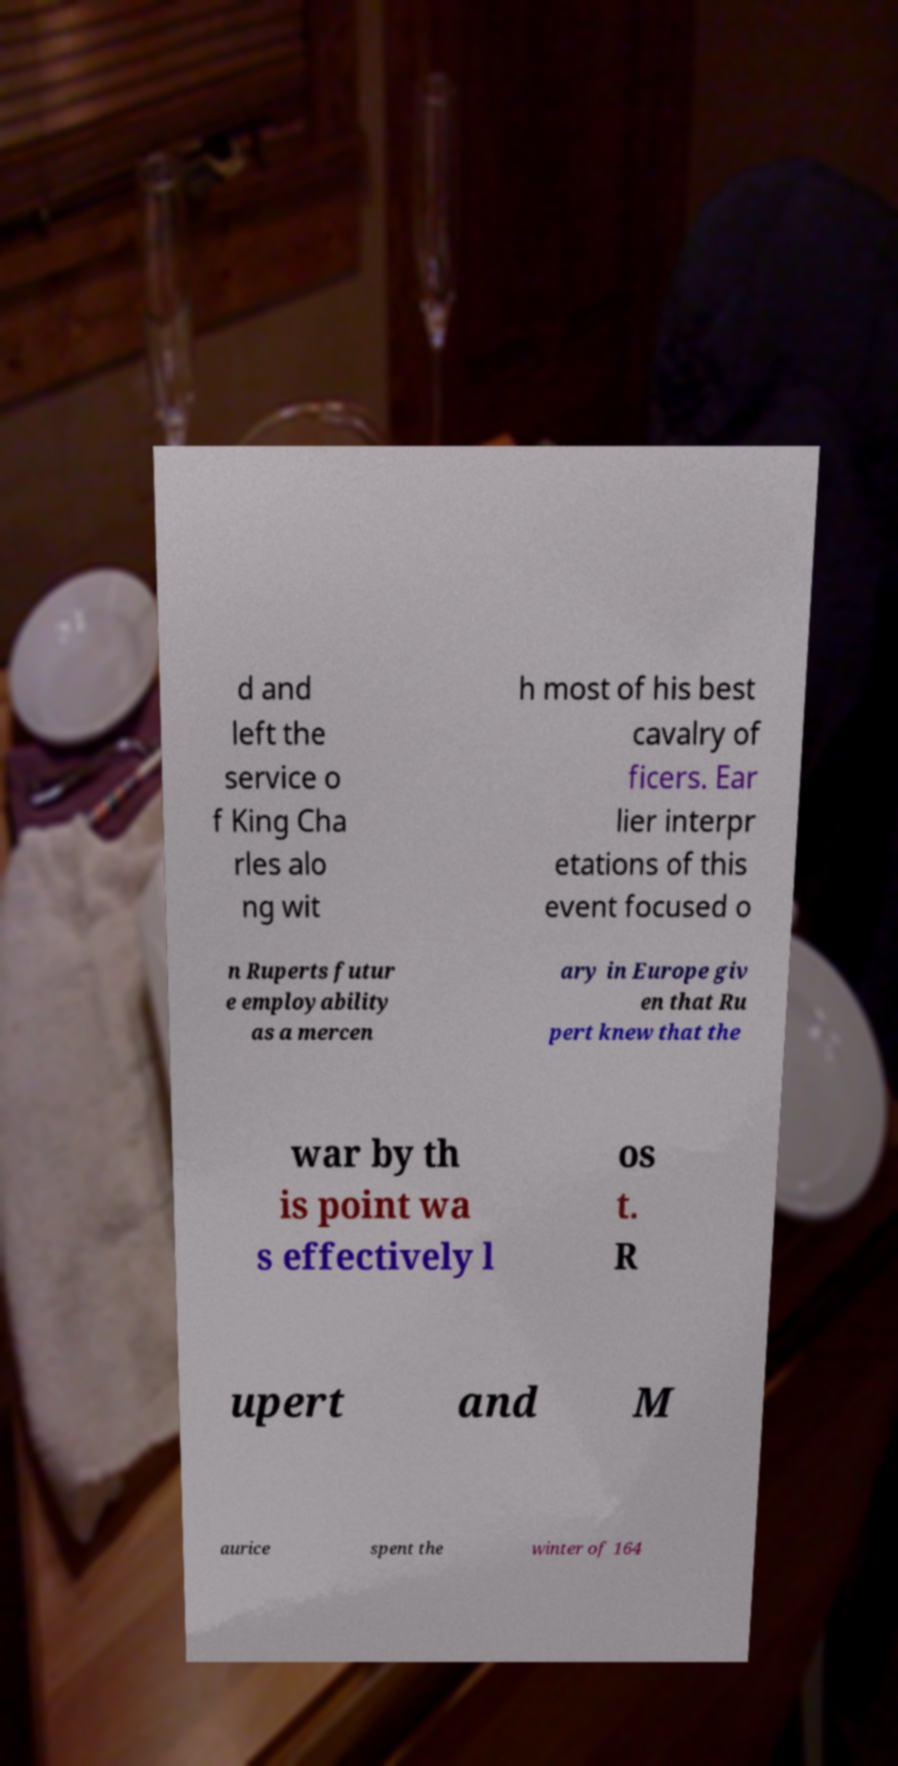Please read and relay the text visible in this image. What does it say? d and left the service o f King Cha rles alo ng wit h most of his best cavalry of ficers. Ear lier interpr etations of this event focused o n Ruperts futur e employability as a mercen ary in Europe giv en that Ru pert knew that the war by th is point wa s effectively l os t. R upert and M aurice spent the winter of 164 